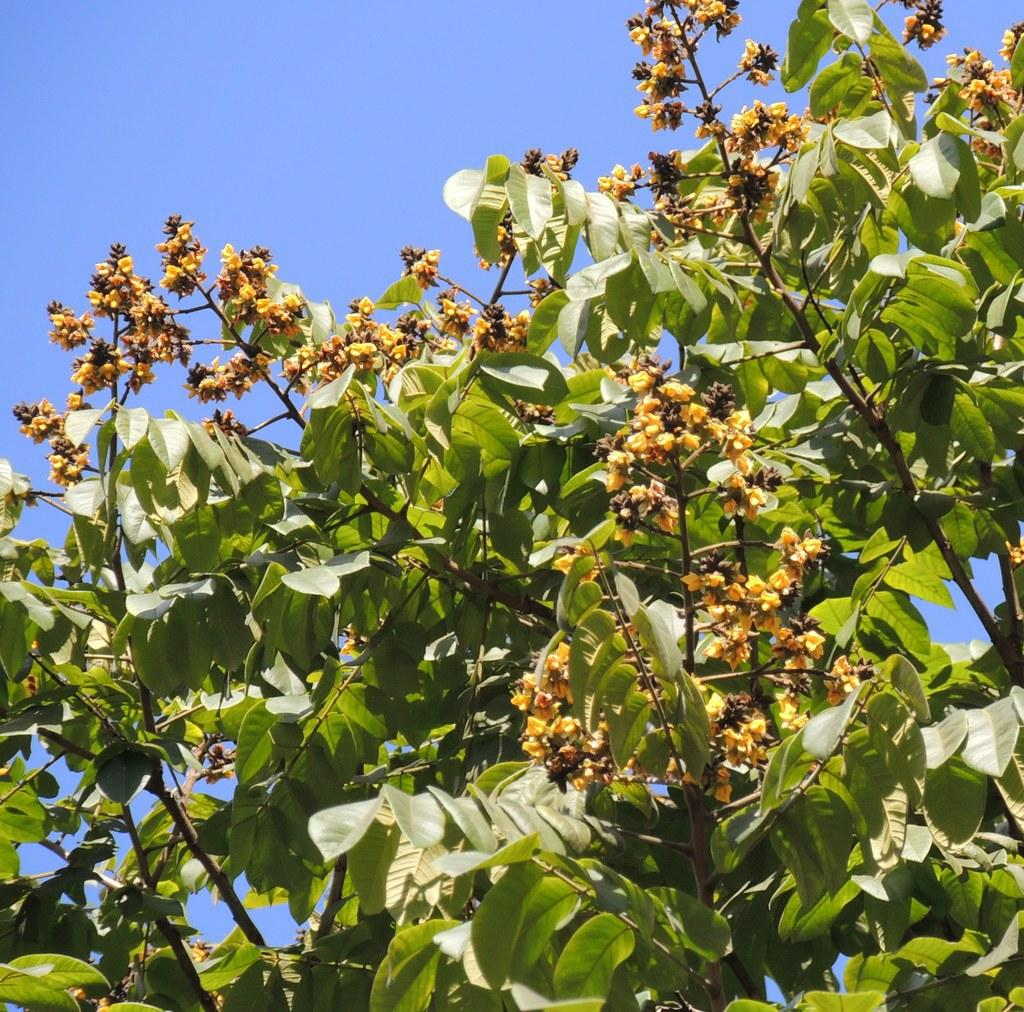What type of flowers can be seen in the image? There are yellow flowers in the image. What color are the leaves associated with the flowers? There are green leaves in the image. How would you describe the sky in the image? The sky is cloudy in the image. How many girls are standing near the mailbox in the alley in the image? There are no girls, mailbox, or alley present in the image. 